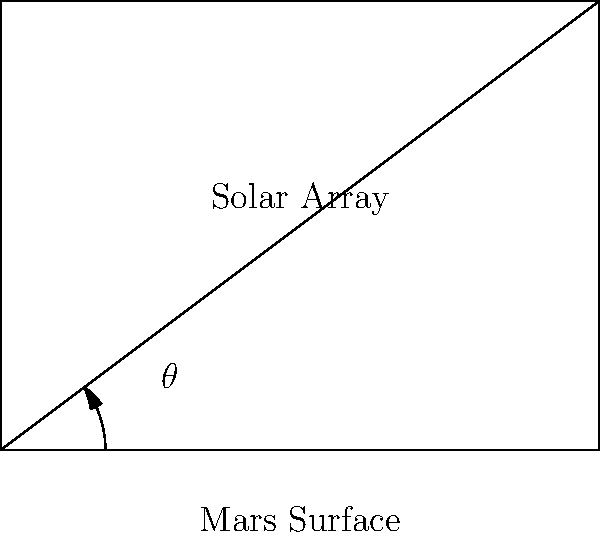As a scientist working on the Mars rover project, you need to determine the optimal angle for the deployable solar arrays. Given that the maximum power output occurs when the solar arrays are perpendicular to the incident sunlight, and the sun's elevation angle on Mars at the landing site is 53.13°, what is the optimal angle $\theta$ (in degrees) for the solar arrays with respect to the Mars surface? To solve this problem, we need to follow these steps:

1. Understand that the optimal angle for the solar arrays is when they are perpendicular to the incident sunlight.

2. Recognize that the sun's elevation angle is given as 53.13°. This is the angle between the sun's rays and the Mars surface.

3. To make the solar arrays perpendicular to the sun's rays, we need to add the complementary angle to the sun's elevation angle.

4. Calculate the complementary angle:
   $90° - 53.13° = 36.87°$

5. Therefore, the optimal angle $\theta$ for the solar arrays with respect to the Mars surface is 36.87°.

This angle ensures that the solar arrays are perpendicular to the incident sunlight, maximizing power output for the Mars rover.
Answer: $36.87°$ 